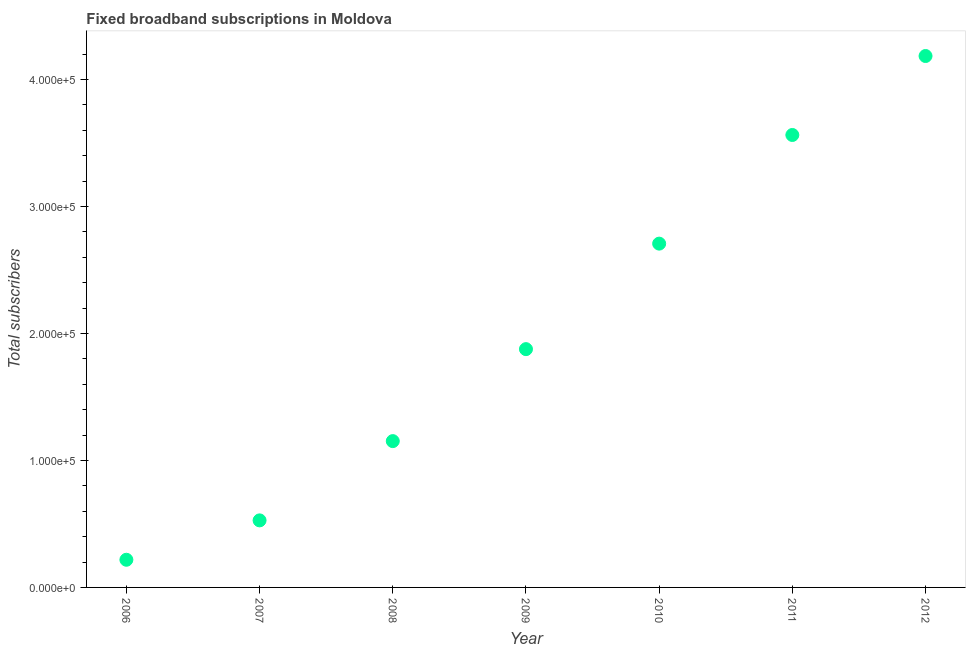What is the total number of fixed broadband subscriptions in 2007?
Ensure brevity in your answer.  5.28e+04. Across all years, what is the maximum total number of fixed broadband subscriptions?
Keep it short and to the point. 4.19e+05. Across all years, what is the minimum total number of fixed broadband subscriptions?
Offer a very short reply. 2.18e+04. In which year was the total number of fixed broadband subscriptions maximum?
Offer a very short reply. 2012. In which year was the total number of fixed broadband subscriptions minimum?
Make the answer very short. 2006. What is the sum of the total number of fixed broadband subscriptions?
Make the answer very short. 1.42e+06. What is the difference between the total number of fixed broadband subscriptions in 2007 and 2012?
Make the answer very short. -3.66e+05. What is the average total number of fixed broadband subscriptions per year?
Make the answer very short. 2.03e+05. What is the median total number of fixed broadband subscriptions?
Your answer should be compact. 1.88e+05. What is the ratio of the total number of fixed broadband subscriptions in 2008 to that in 2009?
Provide a succinct answer. 0.61. Is the total number of fixed broadband subscriptions in 2010 less than that in 2011?
Offer a terse response. Yes. Is the difference between the total number of fixed broadband subscriptions in 2007 and 2012 greater than the difference between any two years?
Provide a short and direct response. No. What is the difference between the highest and the second highest total number of fixed broadband subscriptions?
Your answer should be very brief. 6.22e+04. Is the sum of the total number of fixed broadband subscriptions in 2008 and 2011 greater than the maximum total number of fixed broadband subscriptions across all years?
Your response must be concise. Yes. What is the difference between the highest and the lowest total number of fixed broadband subscriptions?
Make the answer very short. 3.97e+05. In how many years, is the total number of fixed broadband subscriptions greater than the average total number of fixed broadband subscriptions taken over all years?
Keep it short and to the point. 3. How many years are there in the graph?
Provide a succinct answer. 7. Are the values on the major ticks of Y-axis written in scientific E-notation?
Your answer should be very brief. Yes. Does the graph contain grids?
Keep it short and to the point. No. What is the title of the graph?
Your answer should be compact. Fixed broadband subscriptions in Moldova. What is the label or title of the X-axis?
Offer a terse response. Year. What is the label or title of the Y-axis?
Your answer should be compact. Total subscribers. What is the Total subscribers in 2006?
Keep it short and to the point. 2.18e+04. What is the Total subscribers in 2007?
Make the answer very short. 5.28e+04. What is the Total subscribers in 2008?
Offer a very short reply. 1.15e+05. What is the Total subscribers in 2009?
Your answer should be compact. 1.88e+05. What is the Total subscribers in 2010?
Your response must be concise. 2.71e+05. What is the Total subscribers in 2011?
Your response must be concise. 3.56e+05. What is the Total subscribers in 2012?
Provide a succinct answer. 4.19e+05. What is the difference between the Total subscribers in 2006 and 2007?
Give a very brief answer. -3.10e+04. What is the difference between the Total subscribers in 2006 and 2008?
Your answer should be very brief. -9.34e+04. What is the difference between the Total subscribers in 2006 and 2009?
Your response must be concise. -1.66e+05. What is the difference between the Total subscribers in 2006 and 2010?
Your answer should be very brief. -2.49e+05. What is the difference between the Total subscribers in 2006 and 2011?
Offer a terse response. -3.35e+05. What is the difference between the Total subscribers in 2006 and 2012?
Provide a succinct answer. -3.97e+05. What is the difference between the Total subscribers in 2007 and 2008?
Provide a succinct answer. -6.24e+04. What is the difference between the Total subscribers in 2007 and 2009?
Offer a very short reply. -1.35e+05. What is the difference between the Total subscribers in 2007 and 2010?
Make the answer very short. -2.18e+05. What is the difference between the Total subscribers in 2007 and 2011?
Keep it short and to the point. -3.04e+05. What is the difference between the Total subscribers in 2007 and 2012?
Provide a succinct answer. -3.66e+05. What is the difference between the Total subscribers in 2008 and 2009?
Keep it short and to the point. -7.24e+04. What is the difference between the Total subscribers in 2008 and 2010?
Give a very brief answer. -1.56e+05. What is the difference between the Total subscribers in 2008 and 2011?
Your answer should be compact. -2.41e+05. What is the difference between the Total subscribers in 2008 and 2012?
Give a very brief answer. -3.03e+05. What is the difference between the Total subscribers in 2009 and 2010?
Keep it short and to the point. -8.31e+04. What is the difference between the Total subscribers in 2009 and 2011?
Keep it short and to the point. -1.69e+05. What is the difference between the Total subscribers in 2009 and 2012?
Your answer should be very brief. -2.31e+05. What is the difference between the Total subscribers in 2010 and 2011?
Your response must be concise. -8.56e+04. What is the difference between the Total subscribers in 2010 and 2012?
Provide a short and direct response. -1.48e+05. What is the difference between the Total subscribers in 2011 and 2012?
Your answer should be very brief. -6.22e+04. What is the ratio of the Total subscribers in 2006 to that in 2007?
Your response must be concise. 0.41. What is the ratio of the Total subscribers in 2006 to that in 2008?
Your answer should be very brief. 0.19. What is the ratio of the Total subscribers in 2006 to that in 2009?
Make the answer very short. 0.12. What is the ratio of the Total subscribers in 2006 to that in 2010?
Provide a short and direct response. 0.08. What is the ratio of the Total subscribers in 2006 to that in 2011?
Ensure brevity in your answer.  0.06. What is the ratio of the Total subscribers in 2006 to that in 2012?
Ensure brevity in your answer.  0.05. What is the ratio of the Total subscribers in 2007 to that in 2008?
Provide a succinct answer. 0.46. What is the ratio of the Total subscribers in 2007 to that in 2009?
Your response must be concise. 0.28. What is the ratio of the Total subscribers in 2007 to that in 2010?
Ensure brevity in your answer.  0.2. What is the ratio of the Total subscribers in 2007 to that in 2011?
Make the answer very short. 0.15. What is the ratio of the Total subscribers in 2007 to that in 2012?
Your answer should be compact. 0.13. What is the ratio of the Total subscribers in 2008 to that in 2009?
Provide a succinct answer. 0.61. What is the ratio of the Total subscribers in 2008 to that in 2010?
Offer a very short reply. 0.43. What is the ratio of the Total subscribers in 2008 to that in 2011?
Give a very brief answer. 0.32. What is the ratio of the Total subscribers in 2008 to that in 2012?
Ensure brevity in your answer.  0.28. What is the ratio of the Total subscribers in 2009 to that in 2010?
Your answer should be compact. 0.69. What is the ratio of the Total subscribers in 2009 to that in 2011?
Provide a short and direct response. 0.53. What is the ratio of the Total subscribers in 2009 to that in 2012?
Offer a terse response. 0.45. What is the ratio of the Total subscribers in 2010 to that in 2011?
Your response must be concise. 0.76. What is the ratio of the Total subscribers in 2010 to that in 2012?
Ensure brevity in your answer.  0.65. What is the ratio of the Total subscribers in 2011 to that in 2012?
Make the answer very short. 0.85. 